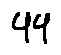Convert formula to latex. <formula><loc_0><loc_0><loc_500><loc_500>4 4</formula> 